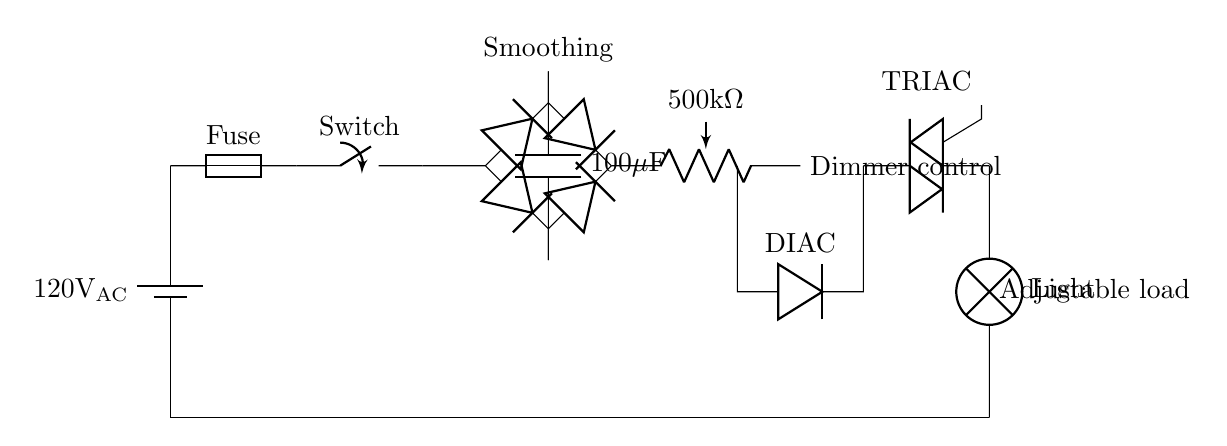What is the power source voltage? The power source voltage is labeled as 120 volts AC at the battery symbol. This indicates the supply voltage for the circuit.
Answer: 120 volts AC What type of component is used for dimming? The component used for dimming is a potentiometer, which is shown in the circuit as a variable resistor. It allows adjustment of resistance to control the light's brightness.
Answer: Potentiometer How many diodes are in the diode bridge? The diode bridge consists of four diodes connected in a way that converts AC to DC. They are usually arranged in a bridge configuration and are essential for this circuit's function.
Answer: Four What is the capacitance value of the capacitor in this circuit? The capacitor is labeled as 100 microfarads, which specifies its ability to smooth the rectified output voltage. This value is critical for determining how well the circuit can filter voltage fluctuations.
Answer: 100 microfarads What type of load is represented in this circuit? The load represented in this circuit is a lamp, which directly converts electrical energy into light, indicating the output of the dimmer circuit.
Answer: Lamp Explain the function of the TRIAC in this circuit. The TRIAC is responsible for controlling the power flow to the lamp. When triggered, it allows current to pass, effectively switching the load on or off depending on the timing provided by the DIMMER CONTROL. This enables the adjustable lighting feature of the circuit.
Answer: Power control 